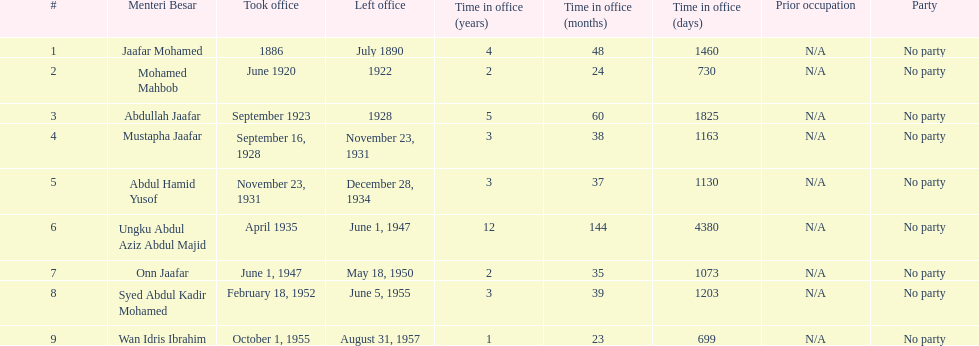What was the date the last person on the list left office? August 31, 1957. 